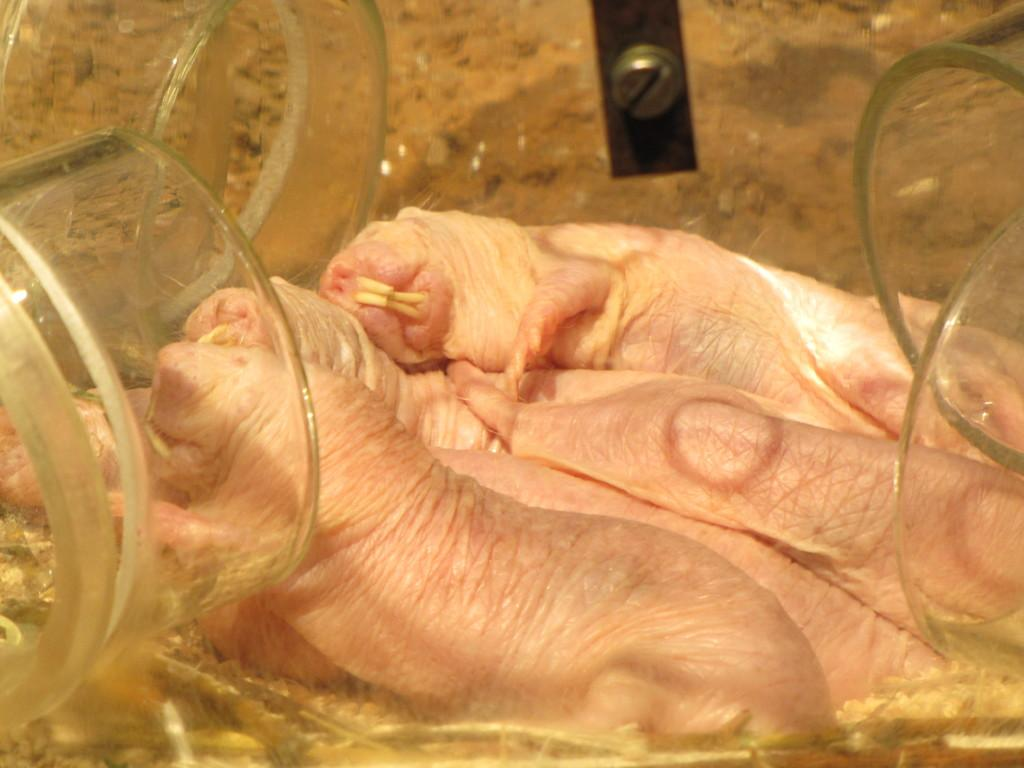What type of animal is the main subject of the image? There is a naked mole rat in the image. What is the other object present in the image? There is a sand puppy in a glass box in the image. Can you describe the glass box? The glass box has screws in some regions. How many planes are flying over the sand puppy in the image? There are no planes present in the image; it only features a naked mole rat and a sand puppy in a glass box. What type of fabric is used to cover the sand puppy in the image? The sand puppy is in a glass box and is not covered by any fabric. 